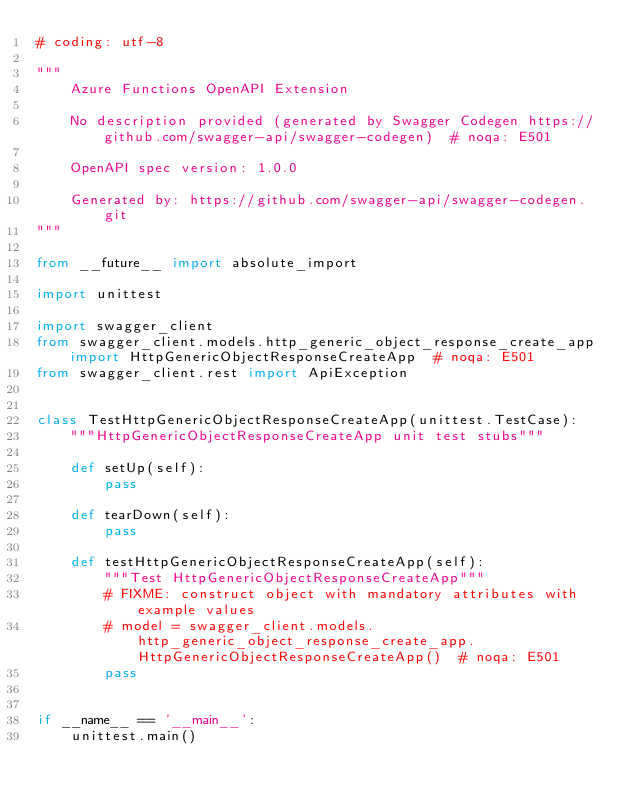<code> <loc_0><loc_0><loc_500><loc_500><_Python_># coding: utf-8

"""
    Azure Functions OpenAPI Extension

    No description provided (generated by Swagger Codegen https://github.com/swagger-api/swagger-codegen)  # noqa: E501

    OpenAPI spec version: 1.0.0
    
    Generated by: https://github.com/swagger-api/swagger-codegen.git
"""

from __future__ import absolute_import

import unittest

import swagger_client
from swagger_client.models.http_generic_object_response_create_app import HttpGenericObjectResponseCreateApp  # noqa: E501
from swagger_client.rest import ApiException


class TestHttpGenericObjectResponseCreateApp(unittest.TestCase):
    """HttpGenericObjectResponseCreateApp unit test stubs"""

    def setUp(self):
        pass

    def tearDown(self):
        pass

    def testHttpGenericObjectResponseCreateApp(self):
        """Test HttpGenericObjectResponseCreateApp"""
        # FIXME: construct object with mandatory attributes with example values
        # model = swagger_client.models.http_generic_object_response_create_app.HttpGenericObjectResponseCreateApp()  # noqa: E501
        pass


if __name__ == '__main__':
    unittest.main()
</code> 